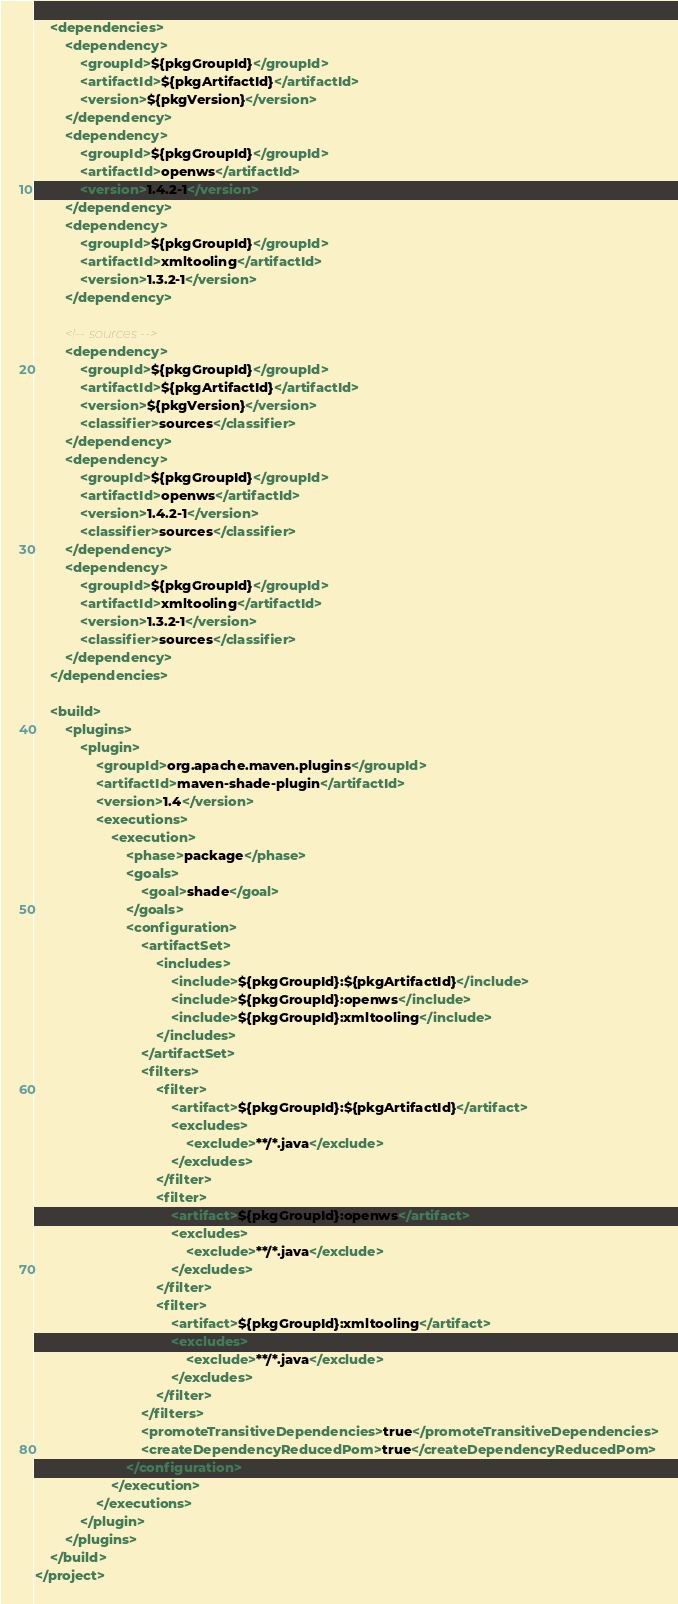Convert code to text. <code><loc_0><loc_0><loc_500><loc_500><_XML_>    <dependencies>
        <dependency>
            <groupId>${pkgGroupId}</groupId>
            <artifactId>${pkgArtifactId}</artifactId>
            <version>${pkgVersion}</version>
        </dependency>
        <dependency>
            <groupId>${pkgGroupId}</groupId>
            <artifactId>openws</artifactId>
            <version>1.4.2-1</version>
        </dependency>
        <dependency>
            <groupId>${pkgGroupId}</groupId>
            <artifactId>xmltooling</artifactId>
            <version>1.3.2-1</version>
        </dependency>

        <!-- sources -->
        <dependency>
            <groupId>${pkgGroupId}</groupId>
            <artifactId>${pkgArtifactId}</artifactId>
            <version>${pkgVersion}</version>
            <classifier>sources</classifier>
        </dependency>
        <dependency>
            <groupId>${pkgGroupId}</groupId>
            <artifactId>openws</artifactId>
            <version>1.4.2-1</version>
            <classifier>sources</classifier>
        </dependency>
        <dependency>
            <groupId>${pkgGroupId}</groupId>
            <artifactId>xmltooling</artifactId>
            <version>1.3.2-1</version>
            <classifier>sources</classifier>
        </dependency>
    </dependencies>

    <build>
        <plugins>
            <plugin>
                <groupId>org.apache.maven.plugins</groupId>
                <artifactId>maven-shade-plugin</artifactId>
                <version>1.4</version>
                <executions>
                    <execution>
                        <phase>package</phase>
                        <goals>
                            <goal>shade</goal>
                        </goals>
                        <configuration>
                            <artifactSet>
                                <includes>
                                    <include>${pkgGroupId}:${pkgArtifactId}</include>
                                    <include>${pkgGroupId}:openws</include>
                                    <include>${pkgGroupId}:xmltooling</include>
                                </includes>
                            </artifactSet>
                            <filters>
                                <filter>
                                    <artifact>${pkgGroupId}:${pkgArtifactId}</artifact>
                                    <excludes>
                                        <exclude>**/*.java</exclude>
                                    </excludes>
                                </filter>
                                <filter>
                                    <artifact>${pkgGroupId}:openws</artifact>
                                    <excludes>
                                        <exclude>**/*.java</exclude>
                                    </excludes>
                                </filter>
                                <filter>
                                    <artifact>${pkgGroupId}:xmltooling</artifact>
                                    <excludes>
                                        <exclude>**/*.java</exclude>
                                    </excludes>
                                </filter>
                            </filters>
                            <promoteTransitiveDependencies>true</promoteTransitiveDependencies>
                            <createDependencyReducedPom>true</createDependencyReducedPom>
                        </configuration>
                    </execution>
                </executions>
            </plugin>
        </plugins>
    </build>
</project>
</code> 